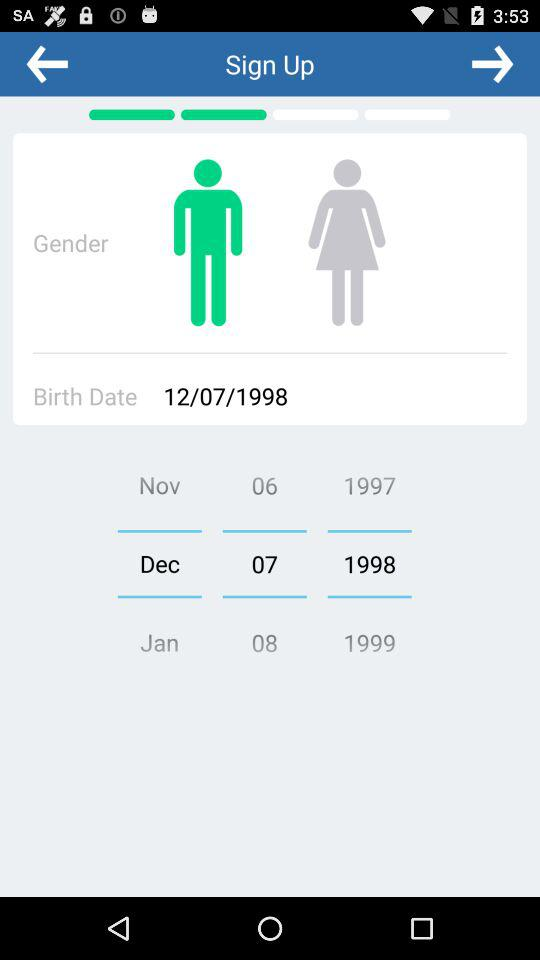How many dates are there in the birth date picker?
Answer the question using a single word or phrase. 3 